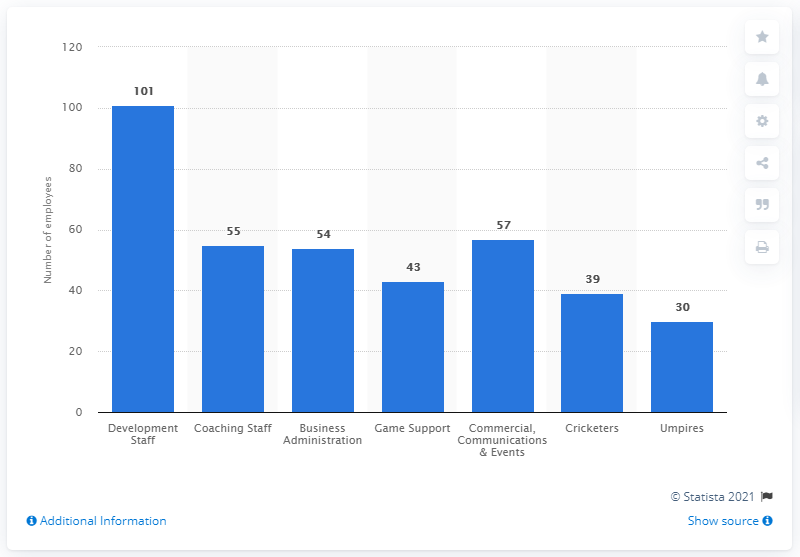Highlight a few significant elements in this photo. As of 2020, there were 101 individuals employed as development staff at the European Central Bank (ECB). 